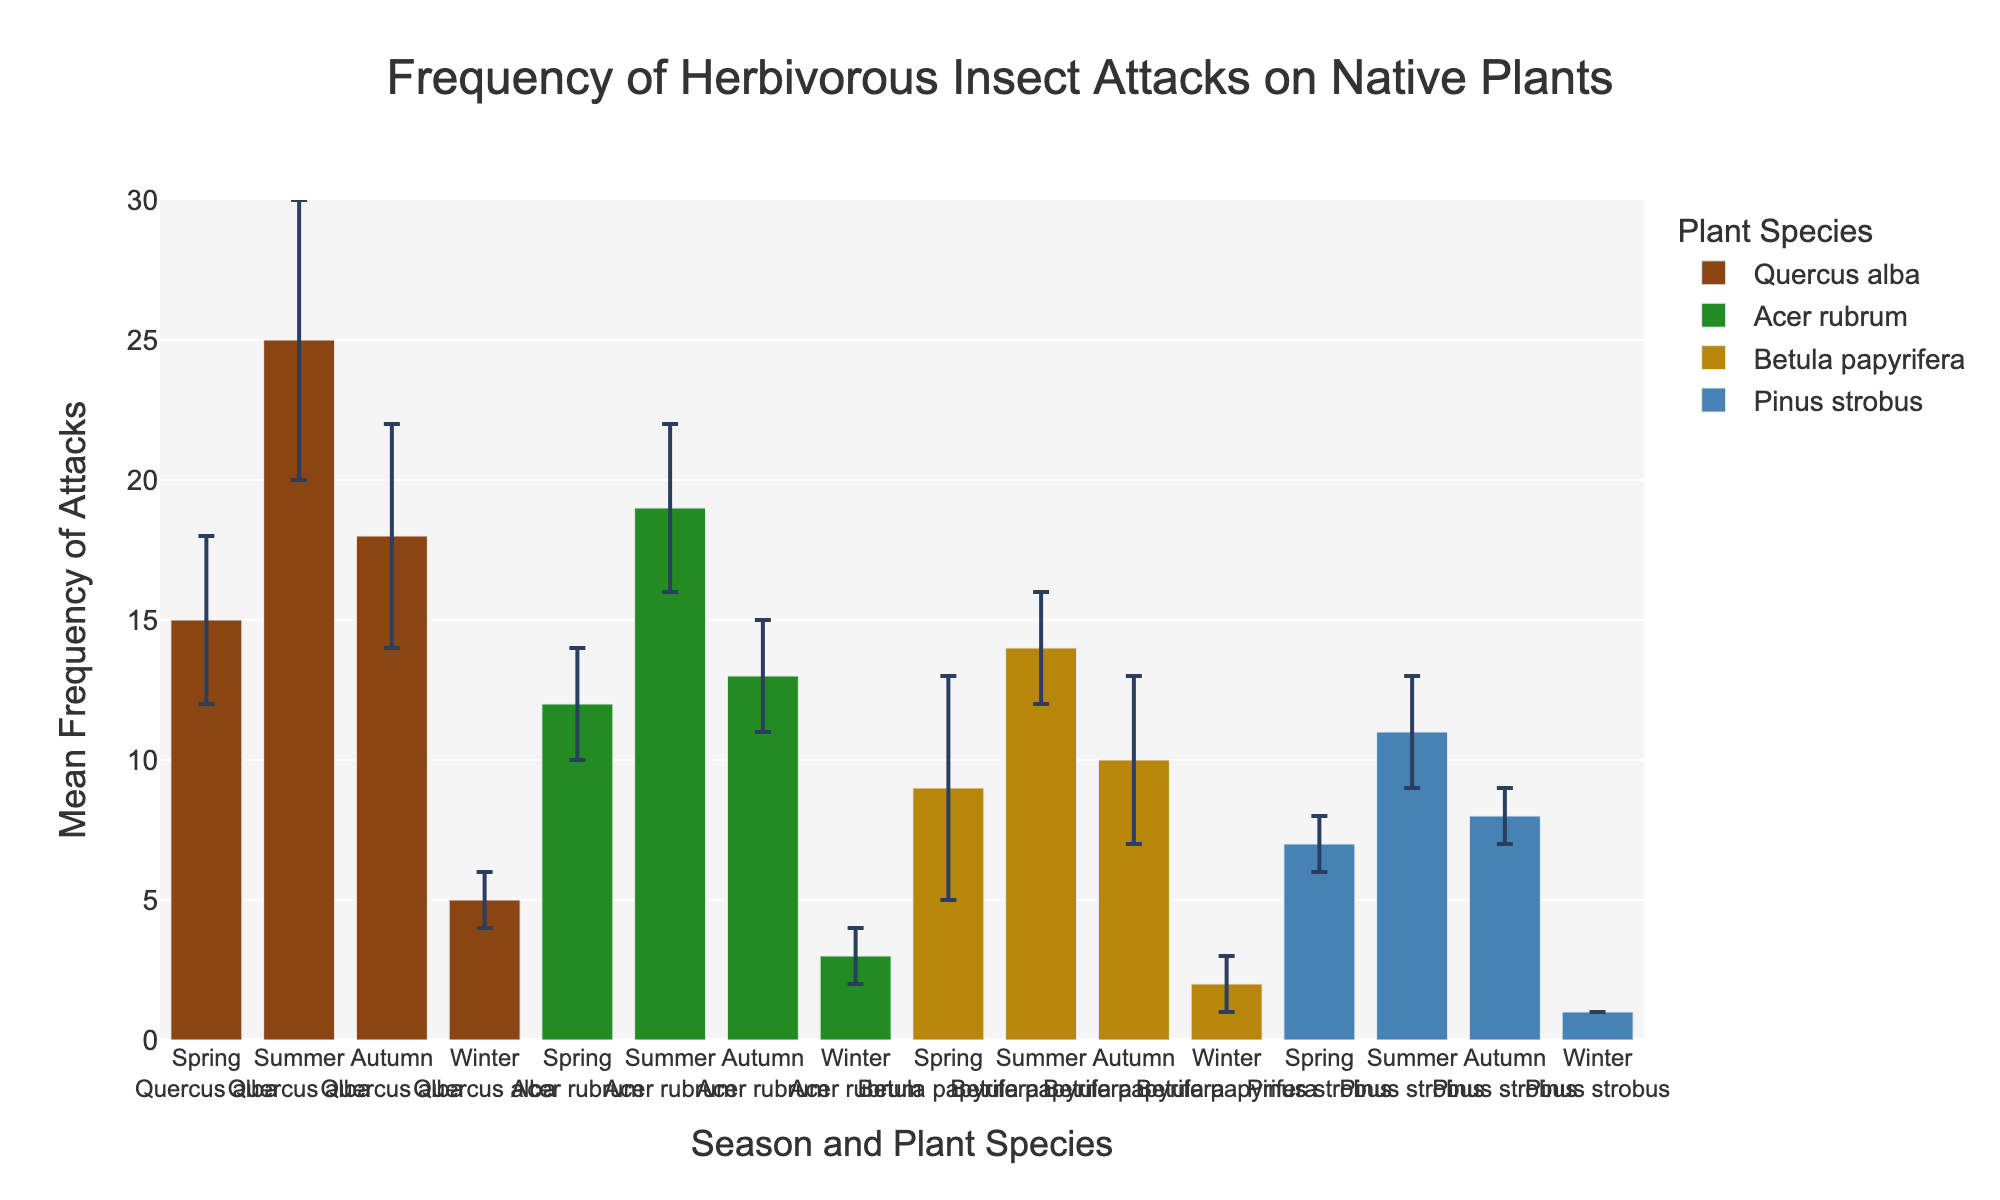What is the title of the chart? The chart title is located at the top of the chart, summarizing the data it presents.
Answer: Frequency of Herbivorous Insect Attacks on Native Plants Which plant species has the highest mean frequency of attacks in summer? To find this, look at the summer bar groups and identify the highest value. Quercus alba has the highest bar in summer.
Answer: Quercus alba How does the mean frequency of attacks on Quercus alba in winter compare to that in autumn? Compare the height of the bars representing Quercus alba in winter and autumn. Winter has a lower mean frequency (5 vs 18).
Answer: Lower In which season does Betula papyrifera experience the highest frequency of attacks, and what is that frequency? Observe the bars for Betula papyrifera in all seasons and identify the highest one. The highest frequency is in summer with a value of 14.
Answer: Summer, 14 What is the difference in mean frequency of attacks on Pinus strobus between spring and autumn? Find the mean frequencies for Pinus strobus in spring and autumn (7 and 8), then calculate the difference (8 - 7).
Answer: 1 Which season shows the least amount of variation in the frequency of herbivorous insect attacks across all plant species? Look at the length of the error bars for all species in each season. Winter has the shortest error bars on average, indicating the least variation.
Answer: Winter What's the average mean frequency of attacks on Acer rubrum across all seasons? Sum the mean frequencies of attacks on Acer rubrum for all seasons (12 + 19 + 13 + 3) and divide by 4.
Answer: 11.75 Which plant species has the largest standard deviation of attacks in any season and in which season does this occur? Look at the error bars for all plant species in each season. Quercus alba in summer has the largest standard deviation (5).
Answer: Quercus alba, summer Does any plant species show a significant increase in attack frequency from spring to summer? Compare the mean frequencies of each plant species from spring to summer. Quercus alba increases from 15 to 25, which is significant.
Answer: Yes, Quercus alba Between Betula papyrifera and Acer rubrum, which has a higher mean frequency of attacks in autumn? Compare the bars for Betula papyrifera and Acer rubrum in autumn. Acer rubrum has a higher mean frequency (13 vs 10).
Answer: Acer rubrum 